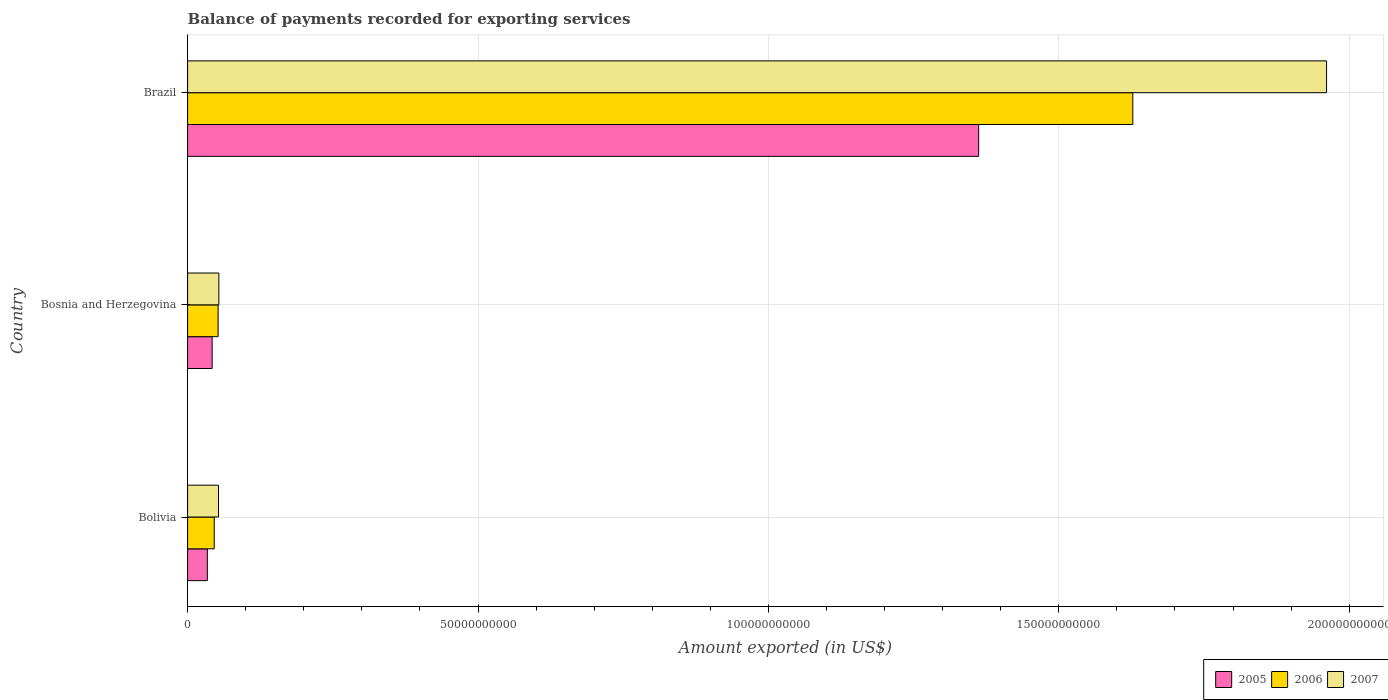How many different coloured bars are there?
Your response must be concise. 3. Are the number of bars per tick equal to the number of legend labels?
Give a very brief answer. Yes. What is the label of the 3rd group of bars from the top?
Provide a succinct answer. Bolivia. In how many cases, is the number of bars for a given country not equal to the number of legend labels?
Ensure brevity in your answer.  0. What is the amount exported in 2005 in Bolivia?
Make the answer very short. 3.40e+09. Across all countries, what is the maximum amount exported in 2006?
Offer a very short reply. 1.63e+11. Across all countries, what is the minimum amount exported in 2006?
Make the answer very short. 4.58e+09. What is the total amount exported in 2005 in the graph?
Provide a succinct answer. 1.44e+11. What is the difference between the amount exported in 2007 in Bolivia and that in Brazil?
Your response must be concise. -1.91e+11. What is the difference between the amount exported in 2006 in Bolivia and the amount exported in 2007 in Bosnia and Herzegovina?
Offer a very short reply. -7.95e+08. What is the average amount exported in 2007 per country?
Provide a short and direct response. 6.89e+1. What is the difference between the amount exported in 2006 and amount exported in 2007 in Brazil?
Your response must be concise. -3.34e+1. In how many countries, is the amount exported in 2005 greater than 190000000000 US$?
Your answer should be compact. 0. What is the ratio of the amount exported in 2005 in Bolivia to that in Bosnia and Herzegovina?
Provide a short and direct response. 0.8. What is the difference between the highest and the second highest amount exported in 2006?
Your response must be concise. 1.57e+11. What is the difference between the highest and the lowest amount exported in 2005?
Provide a short and direct response. 1.33e+11. In how many countries, is the amount exported in 2006 greater than the average amount exported in 2006 taken over all countries?
Your response must be concise. 1. What does the 2nd bar from the top in Brazil represents?
Keep it short and to the point. 2006. How many bars are there?
Make the answer very short. 9. Are all the bars in the graph horizontal?
Your response must be concise. Yes. Does the graph contain any zero values?
Provide a succinct answer. No. Does the graph contain grids?
Ensure brevity in your answer.  Yes. How many legend labels are there?
Your answer should be compact. 3. How are the legend labels stacked?
Keep it short and to the point. Horizontal. What is the title of the graph?
Your answer should be compact. Balance of payments recorded for exporting services. Does "1961" appear as one of the legend labels in the graph?
Make the answer very short. No. What is the label or title of the X-axis?
Provide a short and direct response. Amount exported (in US$). What is the Amount exported (in US$) in 2005 in Bolivia?
Keep it short and to the point. 3.40e+09. What is the Amount exported (in US$) in 2006 in Bolivia?
Provide a short and direct response. 4.58e+09. What is the Amount exported (in US$) in 2007 in Bolivia?
Ensure brevity in your answer.  5.32e+09. What is the Amount exported (in US$) in 2005 in Bosnia and Herzegovina?
Offer a very short reply. 4.23e+09. What is the Amount exported (in US$) of 2006 in Bosnia and Herzegovina?
Make the answer very short. 5.25e+09. What is the Amount exported (in US$) in 2007 in Bosnia and Herzegovina?
Keep it short and to the point. 5.38e+09. What is the Amount exported (in US$) of 2005 in Brazil?
Your response must be concise. 1.36e+11. What is the Amount exported (in US$) of 2006 in Brazil?
Ensure brevity in your answer.  1.63e+11. What is the Amount exported (in US$) in 2007 in Brazil?
Give a very brief answer. 1.96e+11. Across all countries, what is the maximum Amount exported (in US$) in 2005?
Provide a short and direct response. 1.36e+11. Across all countries, what is the maximum Amount exported (in US$) of 2006?
Your answer should be very brief. 1.63e+11. Across all countries, what is the maximum Amount exported (in US$) in 2007?
Keep it short and to the point. 1.96e+11. Across all countries, what is the minimum Amount exported (in US$) of 2005?
Your answer should be compact. 3.40e+09. Across all countries, what is the minimum Amount exported (in US$) of 2006?
Your answer should be compact. 4.58e+09. Across all countries, what is the minimum Amount exported (in US$) of 2007?
Your response must be concise. 5.32e+09. What is the total Amount exported (in US$) in 2005 in the graph?
Keep it short and to the point. 1.44e+11. What is the total Amount exported (in US$) of 2006 in the graph?
Your response must be concise. 1.73e+11. What is the total Amount exported (in US$) of 2007 in the graph?
Your response must be concise. 2.07e+11. What is the difference between the Amount exported (in US$) of 2005 in Bolivia and that in Bosnia and Herzegovina?
Give a very brief answer. -8.26e+08. What is the difference between the Amount exported (in US$) of 2006 in Bolivia and that in Bosnia and Herzegovina?
Offer a very short reply. -6.69e+08. What is the difference between the Amount exported (in US$) in 2007 in Bolivia and that in Bosnia and Herzegovina?
Your answer should be compact. -5.49e+07. What is the difference between the Amount exported (in US$) of 2005 in Bolivia and that in Brazil?
Offer a terse response. -1.33e+11. What is the difference between the Amount exported (in US$) in 2006 in Bolivia and that in Brazil?
Provide a succinct answer. -1.58e+11. What is the difference between the Amount exported (in US$) in 2007 in Bolivia and that in Brazil?
Make the answer very short. -1.91e+11. What is the difference between the Amount exported (in US$) in 2005 in Bosnia and Herzegovina and that in Brazil?
Give a very brief answer. -1.32e+11. What is the difference between the Amount exported (in US$) of 2006 in Bosnia and Herzegovina and that in Brazil?
Provide a succinct answer. -1.57e+11. What is the difference between the Amount exported (in US$) of 2007 in Bosnia and Herzegovina and that in Brazil?
Ensure brevity in your answer.  -1.91e+11. What is the difference between the Amount exported (in US$) of 2005 in Bolivia and the Amount exported (in US$) of 2006 in Bosnia and Herzegovina?
Offer a very short reply. -1.85e+09. What is the difference between the Amount exported (in US$) in 2005 in Bolivia and the Amount exported (in US$) in 2007 in Bosnia and Herzegovina?
Keep it short and to the point. -1.98e+09. What is the difference between the Amount exported (in US$) in 2006 in Bolivia and the Amount exported (in US$) in 2007 in Bosnia and Herzegovina?
Your answer should be very brief. -7.95e+08. What is the difference between the Amount exported (in US$) in 2005 in Bolivia and the Amount exported (in US$) in 2006 in Brazil?
Your response must be concise. -1.59e+11. What is the difference between the Amount exported (in US$) in 2005 in Bolivia and the Amount exported (in US$) in 2007 in Brazil?
Give a very brief answer. -1.93e+11. What is the difference between the Amount exported (in US$) of 2006 in Bolivia and the Amount exported (in US$) of 2007 in Brazil?
Offer a very short reply. -1.92e+11. What is the difference between the Amount exported (in US$) in 2005 in Bosnia and Herzegovina and the Amount exported (in US$) in 2006 in Brazil?
Your response must be concise. -1.59e+11. What is the difference between the Amount exported (in US$) in 2005 in Bosnia and Herzegovina and the Amount exported (in US$) in 2007 in Brazil?
Ensure brevity in your answer.  -1.92e+11. What is the difference between the Amount exported (in US$) of 2006 in Bosnia and Herzegovina and the Amount exported (in US$) of 2007 in Brazil?
Your answer should be compact. -1.91e+11. What is the average Amount exported (in US$) in 2005 per country?
Give a very brief answer. 4.79e+1. What is the average Amount exported (in US$) of 2006 per country?
Ensure brevity in your answer.  5.75e+1. What is the average Amount exported (in US$) of 2007 per country?
Provide a short and direct response. 6.89e+1. What is the difference between the Amount exported (in US$) in 2005 and Amount exported (in US$) in 2006 in Bolivia?
Keep it short and to the point. -1.18e+09. What is the difference between the Amount exported (in US$) in 2005 and Amount exported (in US$) in 2007 in Bolivia?
Offer a very short reply. -1.92e+09. What is the difference between the Amount exported (in US$) of 2006 and Amount exported (in US$) of 2007 in Bolivia?
Your response must be concise. -7.40e+08. What is the difference between the Amount exported (in US$) of 2005 and Amount exported (in US$) of 2006 in Bosnia and Herzegovina?
Provide a short and direct response. -1.03e+09. What is the difference between the Amount exported (in US$) of 2005 and Amount exported (in US$) of 2007 in Bosnia and Herzegovina?
Offer a very short reply. -1.15e+09. What is the difference between the Amount exported (in US$) of 2006 and Amount exported (in US$) of 2007 in Bosnia and Herzegovina?
Your response must be concise. -1.26e+08. What is the difference between the Amount exported (in US$) of 2005 and Amount exported (in US$) of 2006 in Brazil?
Your answer should be very brief. -2.65e+1. What is the difference between the Amount exported (in US$) of 2005 and Amount exported (in US$) of 2007 in Brazil?
Offer a very short reply. -5.99e+1. What is the difference between the Amount exported (in US$) of 2006 and Amount exported (in US$) of 2007 in Brazil?
Ensure brevity in your answer.  -3.34e+1. What is the ratio of the Amount exported (in US$) of 2005 in Bolivia to that in Bosnia and Herzegovina?
Make the answer very short. 0.8. What is the ratio of the Amount exported (in US$) in 2006 in Bolivia to that in Bosnia and Herzegovina?
Provide a short and direct response. 0.87. What is the ratio of the Amount exported (in US$) in 2007 in Bolivia to that in Bosnia and Herzegovina?
Give a very brief answer. 0.99. What is the ratio of the Amount exported (in US$) of 2005 in Bolivia to that in Brazil?
Your answer should be compact. 0.03. What is the ratio of the Amount exported (in US$) in 2006 in Bolivia to that in Brazil?
Make the answer very short. 0.03. What is the ratio of the Amount exported (in US$) in 2007 in Bolivia to that in Brazil?
Give a very brief answer. 0.03. What is the ratio of the Amount exported (in US$) of 2005 in Bosnia and Herzegovina to that in Brazil?
Your answer should be very brief. 0.03. What is the ratio of the Amount exported (in US$) in 2006 in Bosnia and Herzegovina to that in Brazil?
Your answer should be very brief. 0.03. What is the ratio of the Amount exported (in US$) in 2007 in Bosnia and Herzegovina to that in Brazil?
Ensure brevity in your answer.  0.03. What is the difference between the highest and the second highest Amount exported (in US$) of 2005?
Ensure brevity in your answer.  1.32e+11. What is the difference between the highest and the second highest Amount exported (in US$) in 2006?
Ensure brevity in your answer.  1.57e+11. What is the difference between the highest and the second highest Amount exported (in US$) of 2007?
Offer a terse response. 1.91e+11. What is the difference between the highest and the lowest Amount exported (in US$) of 2005?
Give a very brief answer. 1.33e+11. What is the difference between the highest and the lowest Amount exported (in US$) of 2006?
Offer a terse response. 1.58e+11. What is the difference between the highest and the lowest Amount exported (in US$) of 2007?
Give a very brief answer. 1.91e+11. 